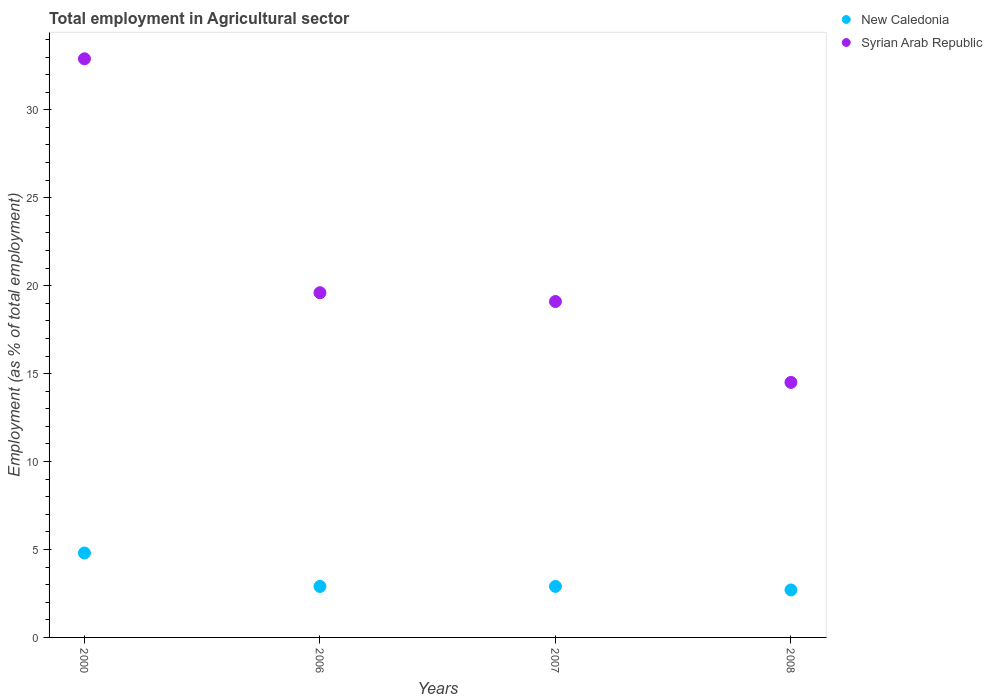How many different coloured dotlines are there?
Your answer should be very brief. 2. Is the number of dotlines equal to the number of legend labels?
Your answer should be compact. Yes. What is the employment in agricultural sector in Syrian Arab Republic in 2006?
Make the answer very short. 19.6. Across all years, what is the maximum employment in agricultural sector in Syrian Arab Republic?
Offer a very short reply. 32.9. Across all years, what is the minimum employment in agricultural sector in New Caledonia?
Ensure brevity in your answer.  2.7. In which year was the employment in agricultural sector in New Caledonia minimum?
Provide a short and direct response. 2008. What is the total employment in agricultural sector in Syrian Arab Republic in the graph?
Provide a succinct answer. 86.1. What is the difference between the employment in agricultural sector in New Caledonia in 2000 and that in 2007?
Offer a very short reply. 1.9. What is the difference between the employment in agricultural sector in Syrian Arab Republic in 2000 and the employment in agricultural sector in New Caledonia in 2007?
Your answer should be compact. 30. What is the average employment in agricultural sector in New Caledonia per year?
Provide a short and direct response. 3.33. In the year 2000, what is the difference between the employment in agricultural sector in New Caledonia and employment in agricultural sector in Syrian Arab Republic?
Provide a succinct answer. -28.1. In how many years, is the employment in agricultural sector in Syrian Arab Republic greater than 26 %?
Provide a succinct answer. 1. What is the ratio of the employment in agricultural sector in New Caledonia in 2006 to that in 2007?
Provide a succinct answer. 1. Is the employment in agricultural sector in New Caledonia in 2007 less than that in 2008?
Provide a succinct answer. No. What is the difference between the highest and the second highest employment in agricultural sector in Syrian Arab Republic?
Make the answer very short. 13.3. What is the difference between the highest and the lowest employment in agricultural sector in New Caledonia?
Give a very brief answer. 2.1. Is the sum of the employment in agricultural sector in New Caledonia in 2007 and 2008 greater than the maximum employment in agricultural sector in Syrian Arab Republic across all years?
Ensure brevity in your answer.  No. Is the employment in agricultural sector in Syrian Arab Republic strictly greater than the employment in agricultural sector in New Caledonia over the years?
Keep it short and to the point. Yes. Is the employment in agricultural sector in Syrian Arab Republic strictly less than the employment in agricultural sector in New Caledonia over the years?
Ensure brevity in your answer.  No. How many dotlines are there?
Your answer should be very brief. 2. Are the values on the major ticks of Y-axis written in scientific E-notation?
Give a very brief answer. No. Does the graph contain any zero values?
Your answer should be very brief. No. Does the graph contain grids?
Keep it short and to the point. No. How many legend labels are there?
Provide a succinct answer. 2. How are the legend labels stacked?
Offer a terse response. Vertical. What is the title of the graph?
Keep it short and to the point. Total employment in Agricultural sector. What is the label or title of the X-axis?
Your answer should be compact. Years. What is the label or title of the Y-axis?
Give a very brief answer. Employment (as % of total employment). What is the Employment (as % of total employment) of New Caledonia in 2000?
Your response must be concise. 4.8. What is the Employment (as % of total employment) in Syrian Arab Republic in 2000?
Keep it short and to the point. 32.9. What is the Employment (as % of total employment) in New Caledonia in 2006?
Ensure brevity in your answer.  2.9. What is the Employment (as % of total employment) of Syrian Arab Republic in 2006?
Give a very brief answer. 19.6. What is the Employment (as % of total employment) of New Caledonia in 2007?
Provide a succinct answer. 2.9. What is the Employment (as % of total employment) in Syrian Arab Republic in 2007?
Your answer should be very brief. 19.1. What is the Employment (as % of total employment) in New Caledonia in 2008?
Offer a very short reply. 2.7. Across all years, what is the maximum Employment (as % of total employment) of New Caledonia?
Give a very brief answer. 4.8. Across all years, what is the maximum Employment (as % of total employment) in Syrian Arab Republic?
Ensure brevity in your answer.  32.9. Across all years, what is the minimum Employment (as % of total employment) of New Caledonia?
Offer a terse response. 2.7. Across all years, what is the minimum Employment (as % of total employment) of Syrian Arab Republic?
Keep it short and to the point. 14.5. What is the total Employment (as % of total employment) in Syrian Arab Republic in the graph?
Offer a very short reply. 86.1. What is the difference between the Employment (as % of total employment) in New Caledonia in 2000 and that in 2007?
Provide a succinct answer. 1.9. What is the difference between the Employment (as % of total employment) of New Caledonia in 2000 and that in 2008?
Your response must be concise. 2.1. What is the difference between the Employment (as % of total employment) of Syrian Arab Republic in 2000 and that in 2008?
Your answer should be very brief. 18.4. What is the difference between the Employment (as % of total employment) in New Caledonia in 2006 and that in 2007?
Provide a short and direct response. 0. What is the difference between the Employment (as % of total employment) of Syrian Arab Republic in 2006 and that in 2007?
Your answer should be compact. 0.5. What is the difference between the Employment (as % of total employment) in New Caledonia in 2006 and that in 2008?
Provide a succinct answer. 0.2. What is the difference between the Employment (as % of total employment) of Syrian Arab Republic in 2006 and that in 2008?
Make the answer very short. 5.1. What is the difference between the Employment (as % of total employment) of New Caledonia in 2007 and that in 2008?
Give a very brief answer. 0.2. What is the difference between the Employment (as % of total employment) of Syrian Arab Republic in 2007 and that in 2008?
Your response must be concise. 4.6. What is the difference between the Employment (as % of total employment) in New Caledonia in 2000 and the Employment (as % of total employment) in Syrian Arab Republic in 2006?
Make the answer very short. -14.8. What is the difference between the Employment (as % of total employment) in New Caledonia in 2000 and the Employment (as % of total employment) in Syrian Arab Republic in 2007?
Provide a succinct answer. -14.3. What is the difference between the Employment (as % of total employment) of New Caledonia in 2000 and the Employment (as % of total employment) of Syrian Arab Republic in 2008?
Offer a terse response. -9.7. What is the difference between the Employment (as % of total employment) in New Caledonia in 2006 and the Employment (as % of total employment) in Syrian Arab Republic in 2007?
Offer a very short reply. -16.2. What is the difference between the Employment (as % of total employment) of New Caledonia in 2007 and the Employment (as % of total employment) of Syrian Arab Republic in 2008?
Offer a very short reply. -11.6. What is the average Employment (as % of total employment) in New Caledonia per year?
Ensure brevity in your answer.  3.33. What is the average Employment (as % of total employment) of Syrian Arab Republic per year?
Keep it short and to the point. 21.52. In the year 2000, what is the difference between the Employment (as % of total employment) of New Caledonia and Employment (as % of total employment) of Syrian Arab Republic?
Give a very brief answer. -28.1. In the year 2006, what is the difference between the Employment (as % of total employment) in New Caledonia and Employment (as % of total employment) in Syrian Arab Republic?
Make the answer very short. -16.7. In the year 2007, what is the difference between the Employment (as % of total employment) in New Caledonia and Employment (as % of total employment) in Syrian Arab Republic?
Your answer should be very brief. -16.2. In the year 2008, what is the difference between the Employment (as % of total employment) in New Caledonia and Employment (as % of total employment) in Syrian Arab Republic?
Provide a succinct answer. -11.8. What is the ratio of the Employment (as % of total employment) of New Caledonia in 2000 to that in 2006?
Give a very brief answer. 1.66. What is the ratio of the Employment (as % of total employment) of Syrian Arab Republic in 2000 to that in 2006?
Offer a very short reply. 1.68. What is the ratio of the Employment (as % of total employment) in New Caledonia in 2000 to that in 2007?
Offer a terse response. 1.66. What is the ratio of the Employment (as % of total employment) of Syrian Arab Republic in 2000 to that in 2007?
Ensure brevity in your answer.  1.72. What is the ratio of the Employment (as % of total employment) in New Caledonia in 2000 to that in 2008?
Keep it short and to the point. 1.78. What is the ratio of the Employment (as % of total employment) in Syrian Arab Republic in 2000 to that in 2008?
Make the answer very short. 2.27. What is the ratio of the Employment (as % of total employment) of Syrian Arab Republic in 2006 to that in 2007?
Ensure brevity in your answer.  1.03. What is the ratio of the Employment (as % of total employment) of New Caledonia in 2006 to that in 2008?
Your answer should be compact. 1.07. What is the ratio of the Employment (as % of total employment) of Syrian Arab Republic in 2006 to that in 2008?
Provide a short and direct response. 1.35. What is the ratio of the Employment (as % of total employment) of New Caledonia in 2007 to that in 2008?
Give a very brief answer. 1.07. What is the ratio of the Employment (as % of total employment) of Syrian Arab Republic in 2007 to that in 2008?
Your answer should be very brief. 1.32. What is the difference between the highest and the second highest Employment (as % of total employment) of New Caledonia?
Keep it short and to the point. 1.9. What is the difference between the highest and the second highest Employment (as % of total employment) in Syrian Arab Republic?
Offer a very short reply. 13.3. What is the difference between the highest and the lowest Employment (as % of total employment) of New Caledonia?
Make the answer very short. 2.1. 